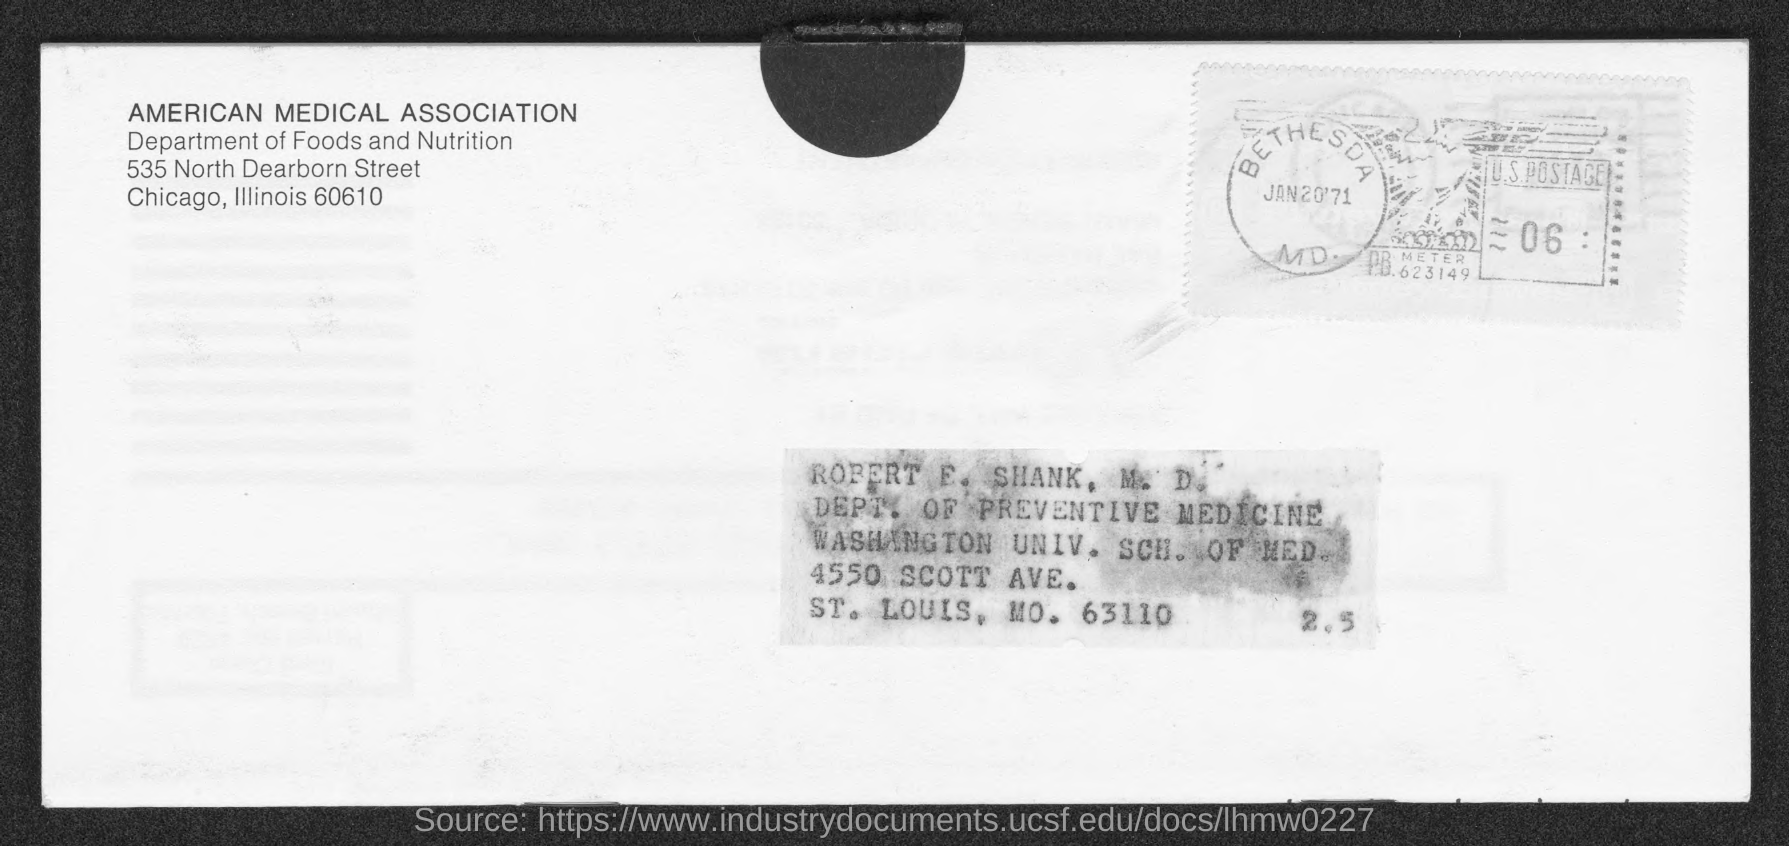What is the date in the seal?
Give a very brief answer. Jan20'71. 